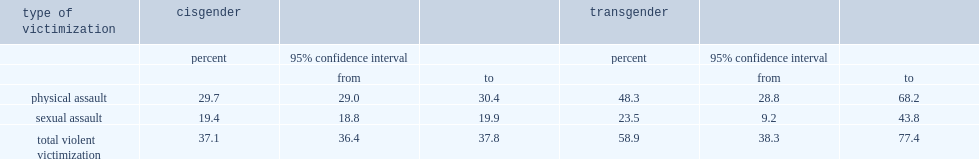Which group of people has a higher proportion of people reporting that they had experienced physical or sexual assault in their lifetimes? transgender canadians or cisgender canadians? Transgender. 